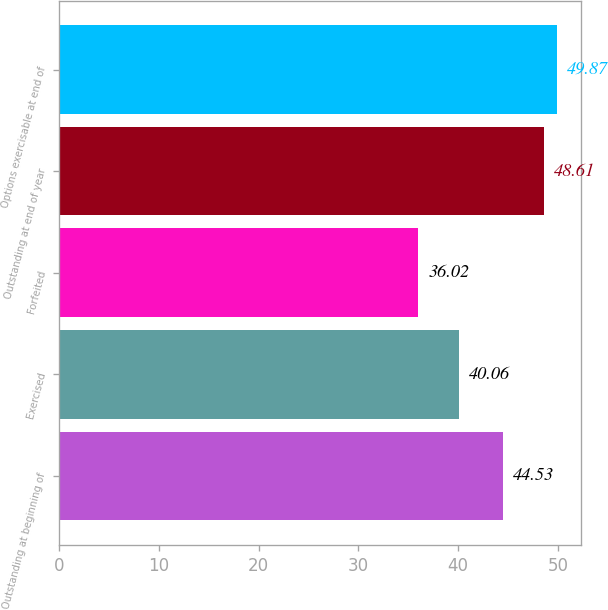Convert chart. <chart><loc_0><loc_0><loc_500><loc_500><bar_chart><fcel>Outstanding at beginning of<fcel>Exercised<fcel>Forfeited<fcel>Outstanding at end of year<fcel>Options exercisable at end of<nl><fcel>44.53<fcel>40.06<fcel>36.02<fcel>48.61<fcel>49.87<nl></chart> 